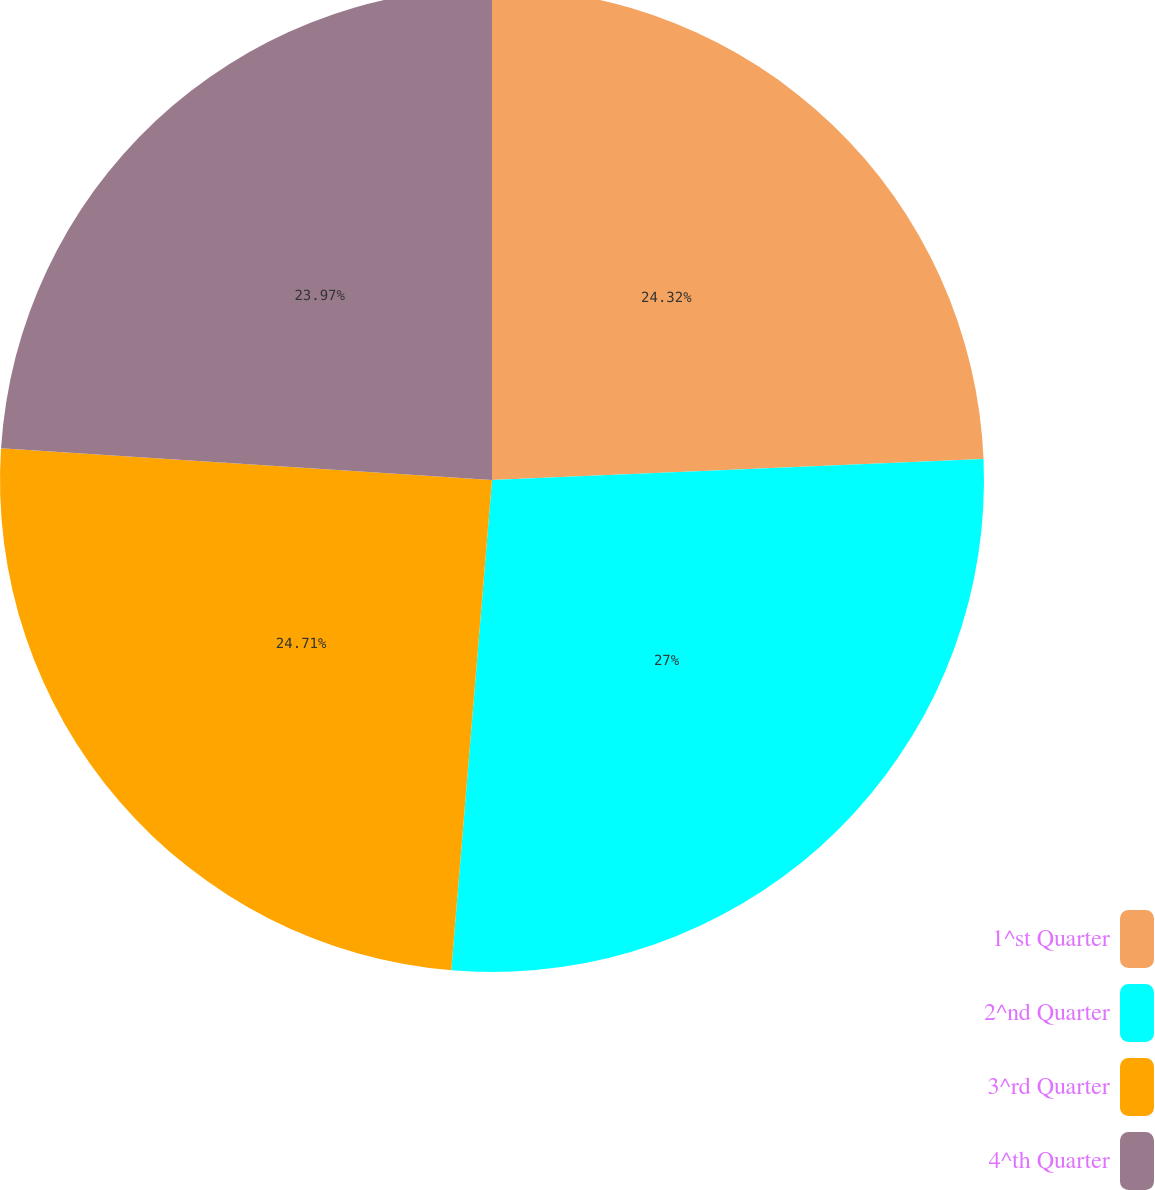Convert chart to OTSL. <chart><loc_0><loc_0><loc_500><loc_500><pie_chart><fcel>1^st Quarter<fcel>2^nd Quarter<fcel>3^rd Quarter<fcel>4^th Quarter<nl><fcel>24.32%<fcel>27.0%<fcel>24.71%<fcel>23.97%<nl></chart> 